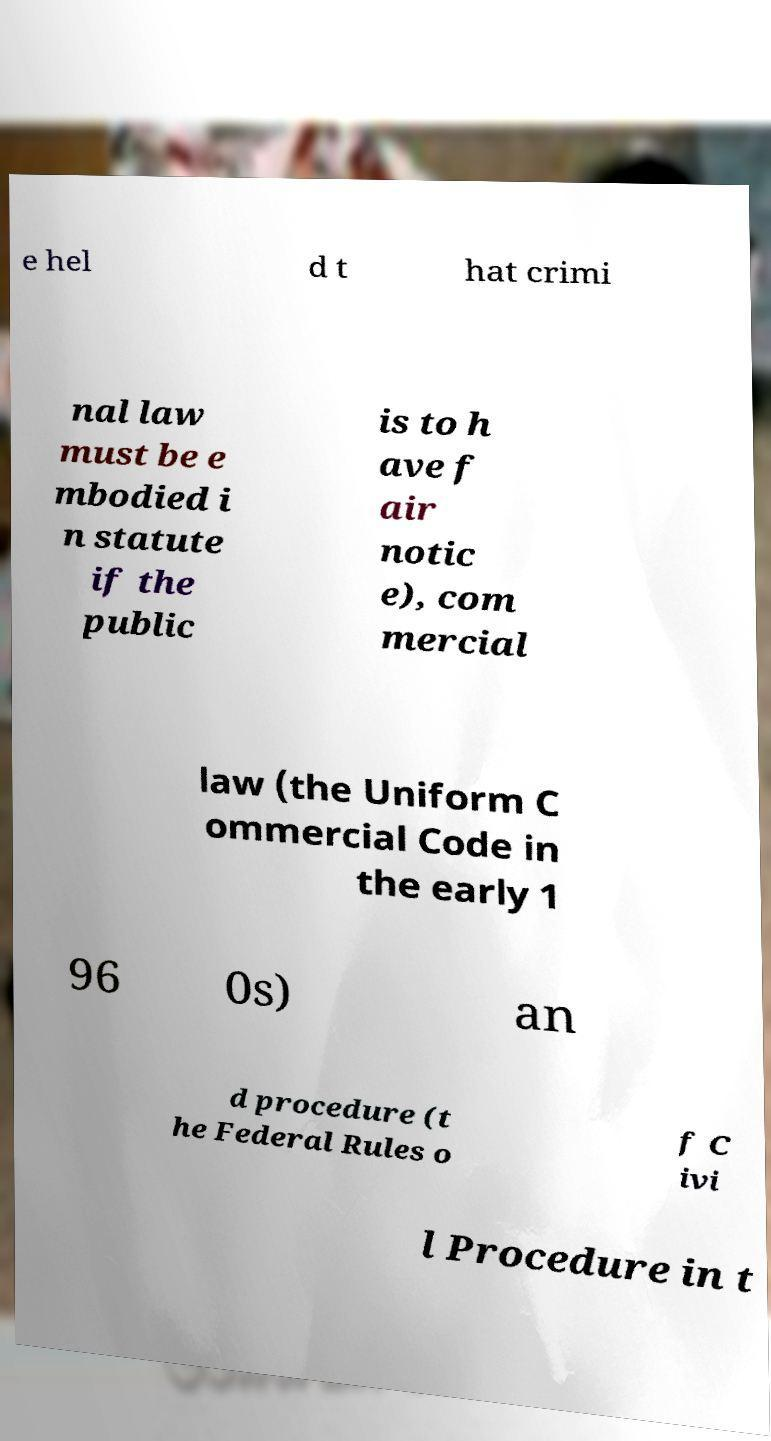Can you read and provide the text displayed in the image?This photo seems to have some interesting text. Can you extract and type it out for me? e hel d t hat crimi nal law must be e mbodied i n statute if the public is to h ave f air notic e), com mercial law (the Uniform C ommercial Code in the early 1 96 0s) an d procedure (t he Federal Rules o f C ivi l Procedure in t 